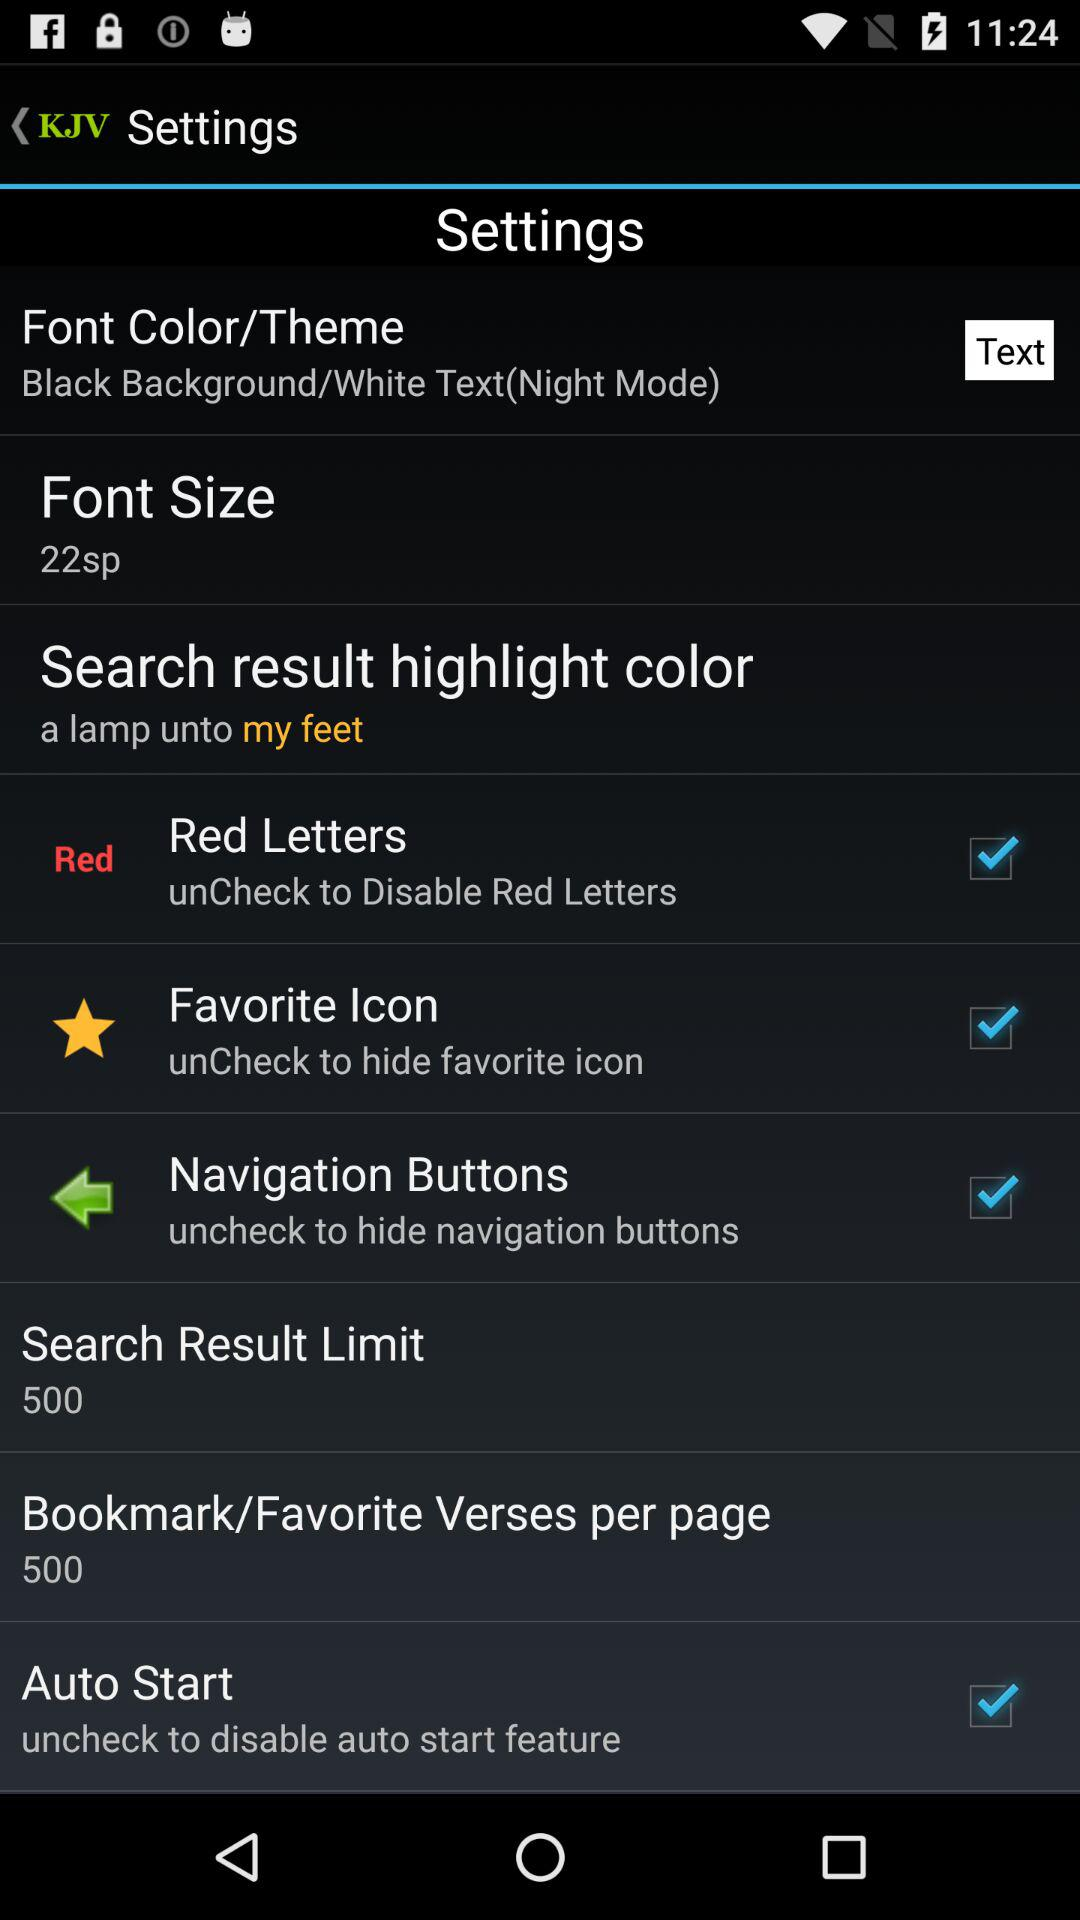What is the status of "Auto Start"? The status is "on". 